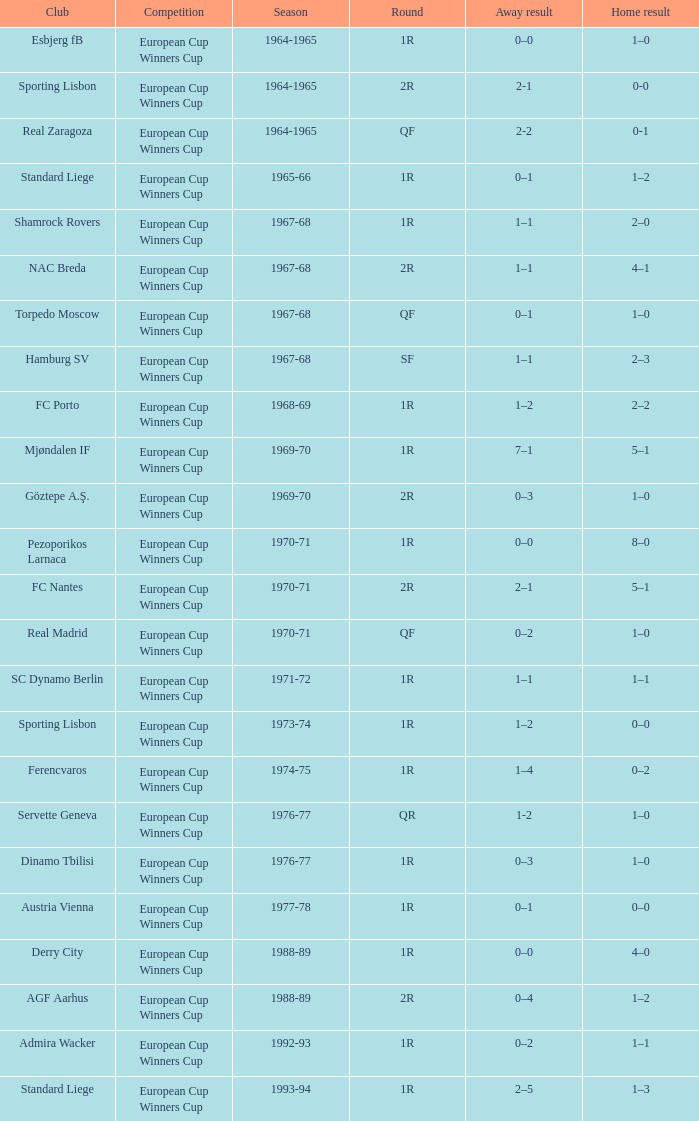Away result of 0–3, and a Season of 1969-70 is what competition? European Cup Winners Cup. 